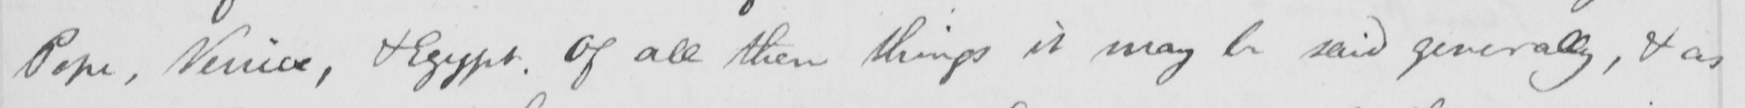What does this handwritten line say? Pope , Venice , & Egypt . Of all these things it may be said generally , & as 